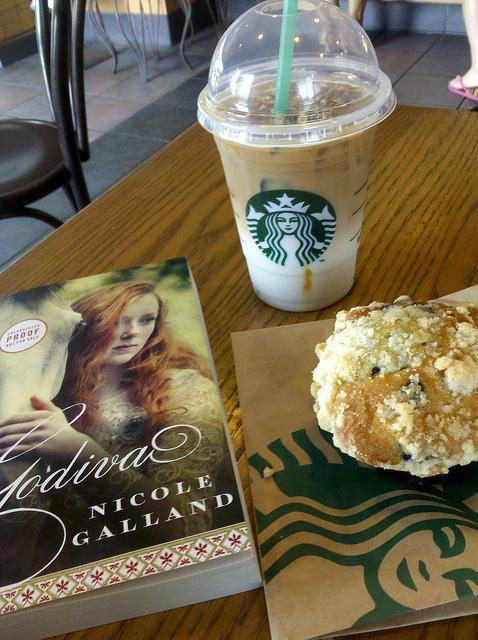How many chairs are there?
Give a very brief answer. 2. 